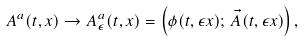Convert formula to latex. <formula><loc_0><loc_0><loc_500><loc_500>A ^ { a } ( t , x ) \to A _ { \epsilon } ^ { a } ( t , x ) = \left ( \phi ( t , \epsilon x ) ; \, \vec { A } ( t , \epsilon x ) \right ) ,</formula> 